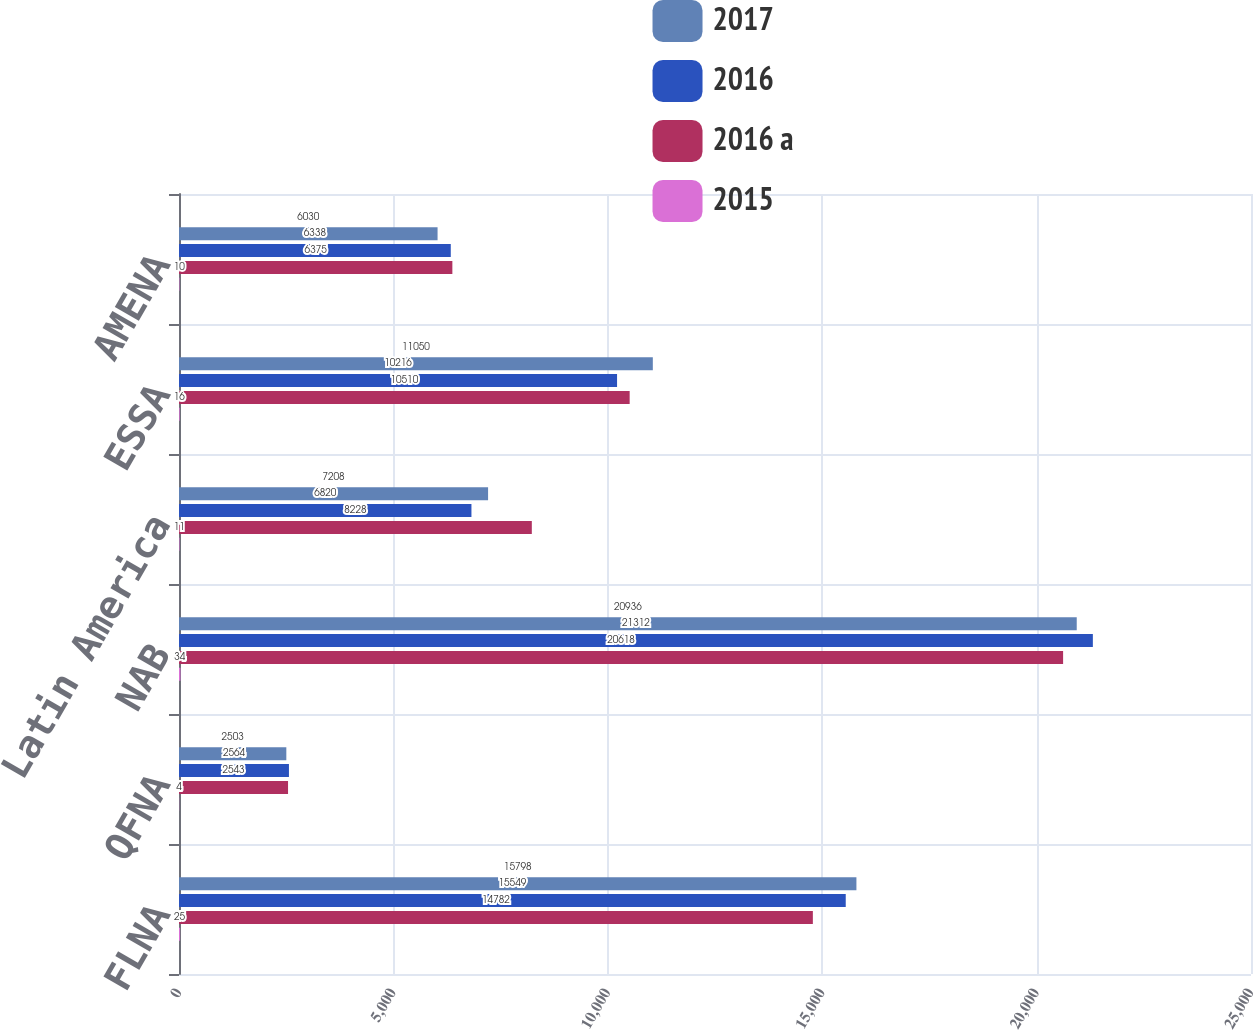Convert chart. <chart><loc_0><loc_0><loc_500><loc_500><stacked_bar_chart><ecel><fcel>FLNA<fcel>QFNA<fcel>NAB<fcel>Latin America<fcel>ESSA<fcel>AMENA<nl><fcel>2017<fcel>15798<fcel>2503<fcel>20936<fcel>7208<fcel>11050<fcel>6030<nl><fcel>2016<fcel>15549<fcel>2564<fcel>21312<fcel>6820<fcel>10216<fcel>6338<nl><fcel>2016 a<fcel>14782<fcel>2543<fcel>20618<fcel>8228<fcel>10510<fcel>6375<nl><fcel>2015<fcel>25<fcel>4<fcel>34<fcel>11<fcel>16<fcel>10<nl></chart> 